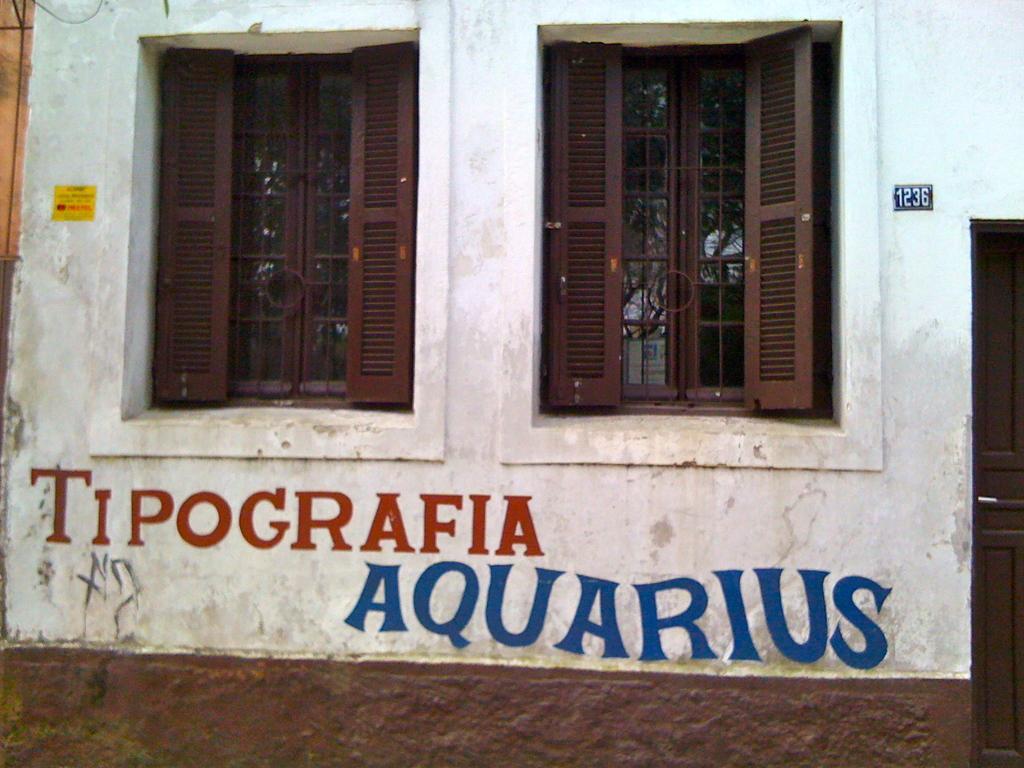Can you describe this image briefly? In this image we can see a building, on the building, we can see some text, there are windows and a door, through the window, we can see the trees. 